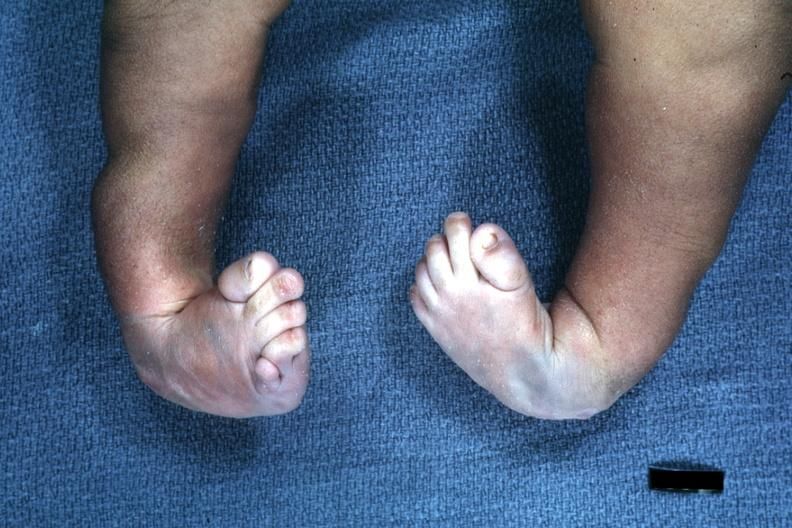re extremities present?
Answer the question using a single word or phrase. Yes 